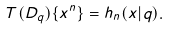Convert formula to latex. <formula><loc_0><loc_0><loc_500><loc_500>T ( D _ { q } ) \{ x ^ { n } \} = h _ { n } ( x | q ) .</formula> 